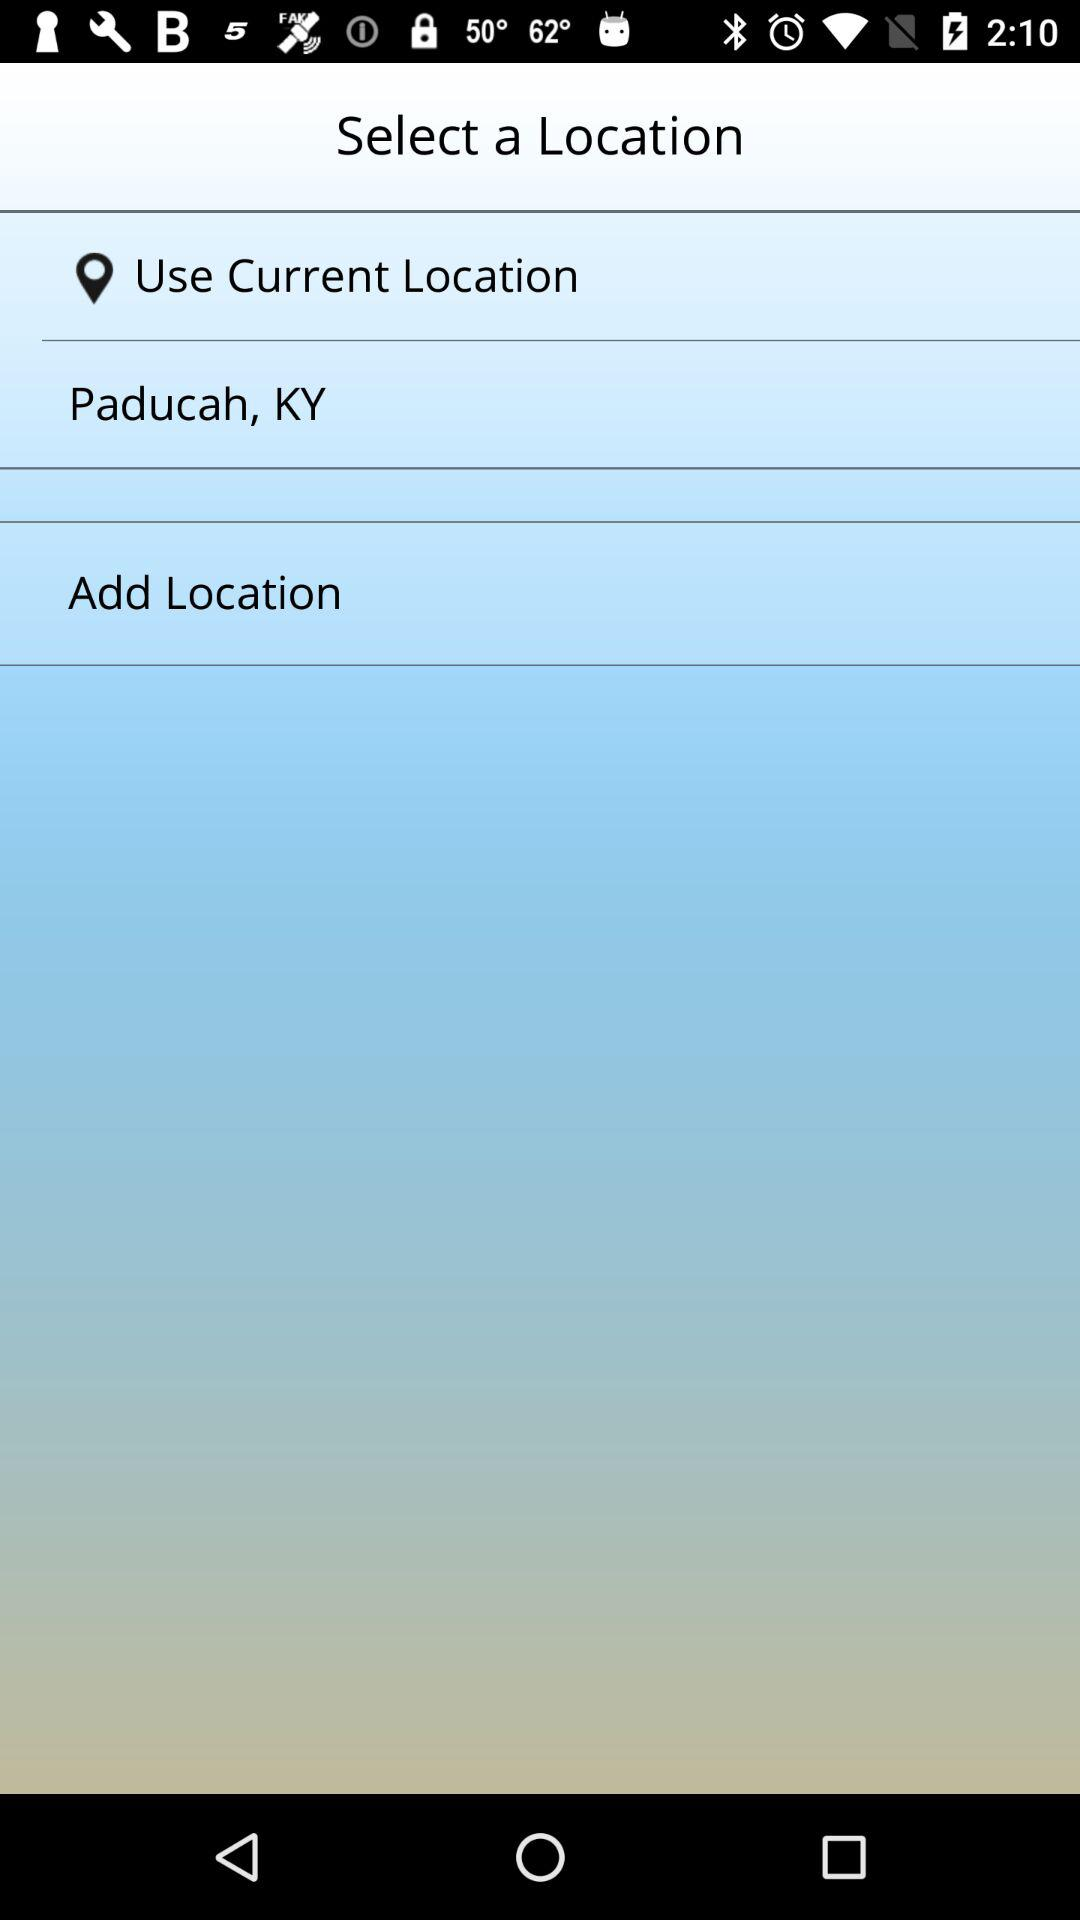What location is given? The location is " Paducah, KY". 